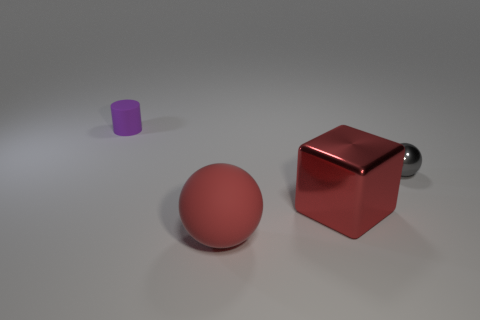Add 1 small purple matte blocks. How many objects exist? 5 Subtract all cylinders. How many objects are left? 3 Add 3 yellow metallic balls. How many yellow metallic balls exist? 3 Subtract 0 brown balls. How many objects are left? 4 Subtract all large balls. Subtract all small cylinders. How many objects are left? 2 Add 4 red matte things. How many red matte things are left? 5 